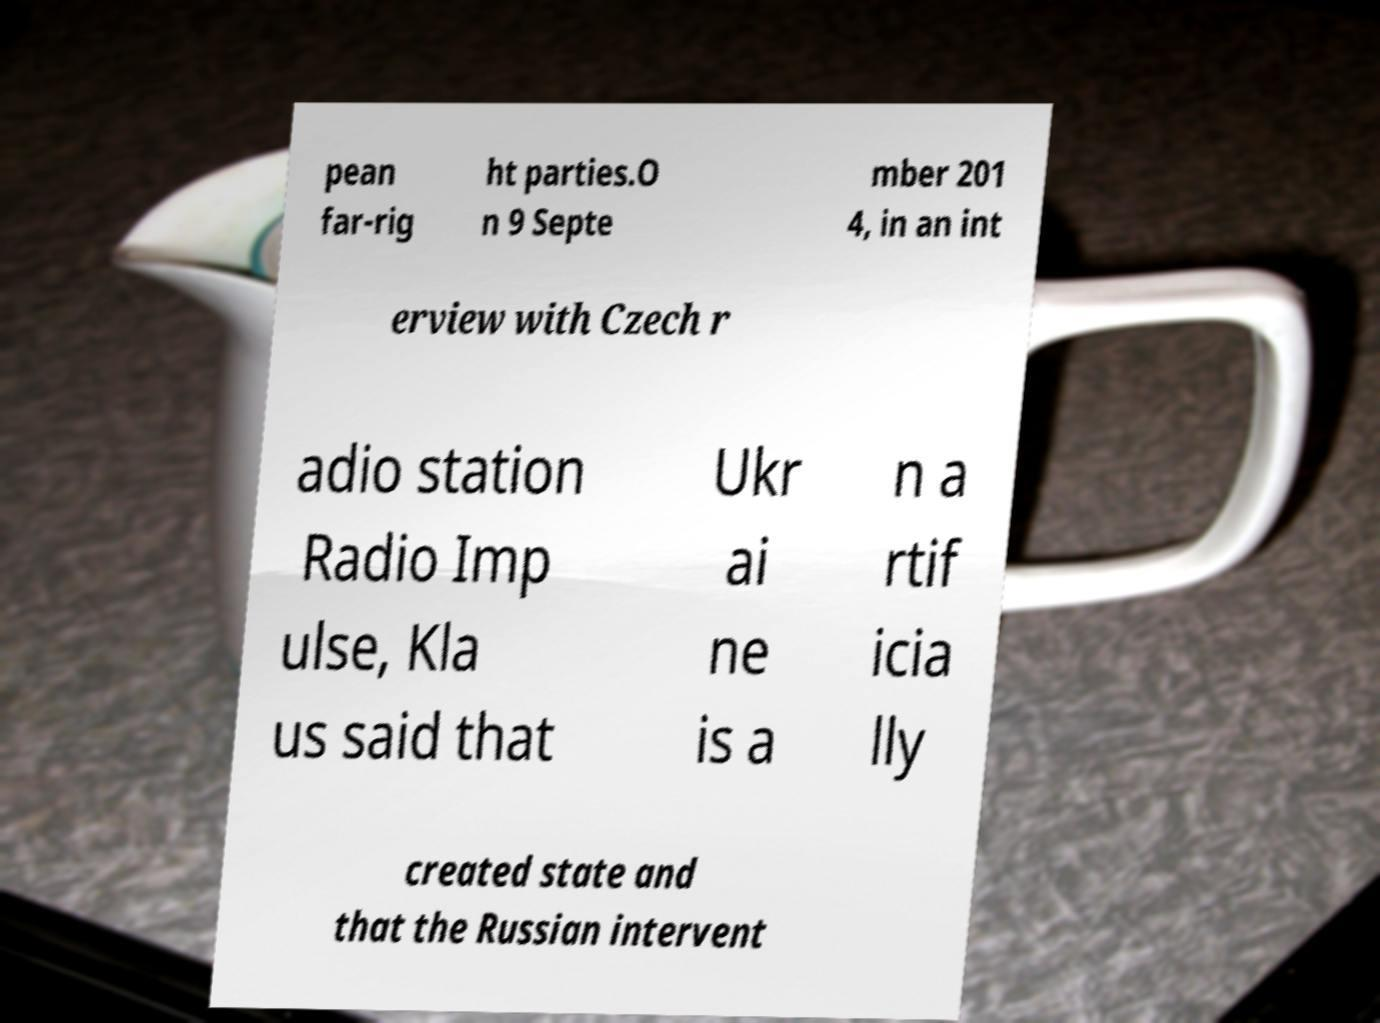Please identify and transcribe the text found in this image. pean far-rig ht parties.O n 9 Septe mber 201 4, in an int erview with Czech r adio station Radio Imp ulse, Kla us said that Ukr ai ne is a n a rtif icia lly created state and that the Russian intervent 